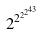Convert formula to latex. <formula><loc_0><loc_0><loc_500><loc_500>2 ^ { 2 ^ { 2 ^ { 2 ^ { 4 3 } } } }</formula> 